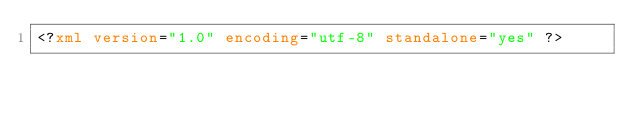<code> <loc_0><loc_0><loc_500><loc_500><_XML_><?xml version="1.0" encoding="utf-8" standalone="yes" ?></code> 